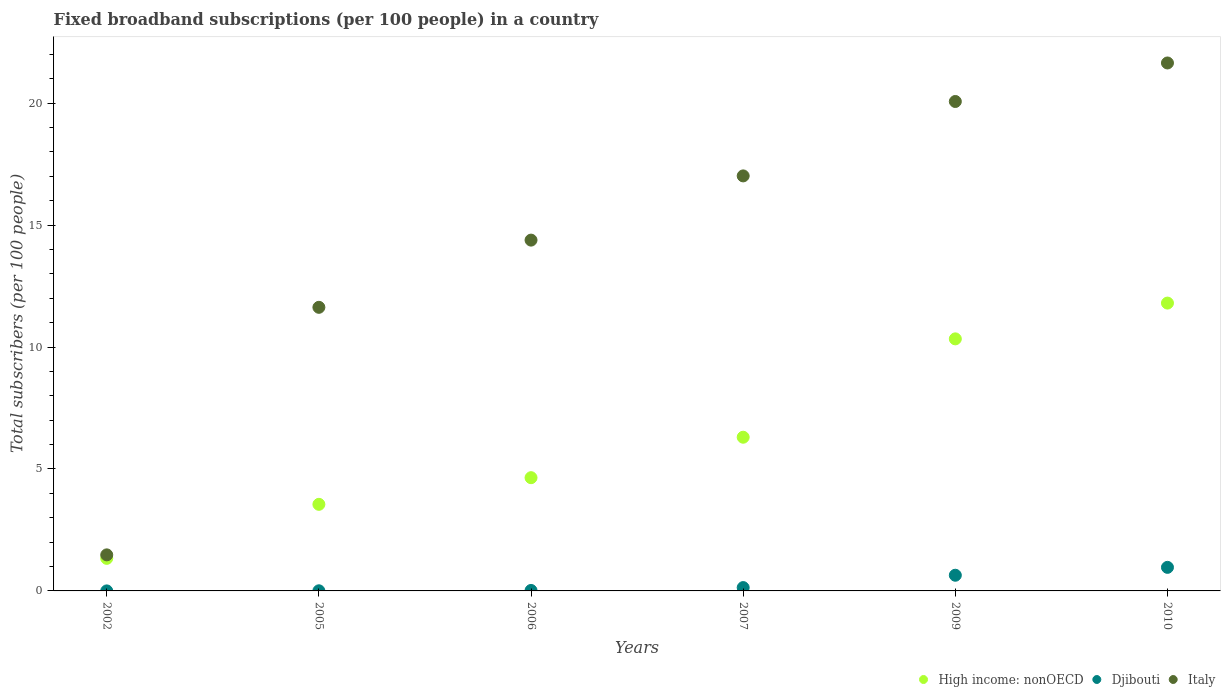What is the number of broadband subscriptions in Italy in 2009?
Provide a short and direct response. 20.07. Across all years, what is the maximum number of broadband subscriptions in Italy?
Provide a short and direct response. 21.65. Across all years, what is the minimum number of broadband subscriptions in Djibouti?
Make the answer very short. 0. In which year was the number of broadband subscriptions in Djibouti maximum?
Offer a terse response. 2010. What is the total number of broadband subscriptions in Djibouti in the graph?
Keep it short and to the point. 1.77. What is the difference between the number of broadband subscriptions in Italy in 2002 and that in 2005?
Keep it short and to the point. -10.15. What is the difference between the number of broadband subscriptions in Djibouti in 2002 and the number of broadband subscriptions in Italy in 2005?
Ensure brevity in your answer.  -11.63. What is the average number of broadband subscriptions in Djibouti per year?
Make the answer very short. 0.3. In the year 2006, what is the difference between the number of broadband subscriptions in High income: nonOECD and number of broadband subscriptions in Djibouti?
Your answer should be compact. 4.62. What is the ratio of the number of broadband subscriptions in High income: nonOECD in 2002 to that in 2009?
Your answer should be very brief. 0.13. Is the number of broadband subscriptions in High income: nonOECD in 2002 less than that in 2009?
Your answer should be very brief. Yes. Is the difference between the number of broadband subscriptions in High income: nonOECD in 2007 and 2009 greater than the difference between the number of broadband subscriptions in Djibouti in 2007 and 2009?
Make the answer very short. No. What is the difference between the highest and the second highest number of broadband subscriptions in Djibouti?
Offer a terse response. 0.32. What is the difference between the highest and the lowest number of broadband subscriptions in High income: nonOECD?
Your answer should be compact. 10.47. Is it the case that in every year, the sum of the number of broadband subscriptions in Italy and number of broadband subscriptions in High income: nonOECD  is greater than the number of broadband subscriptions in Djibouti?
Give a very brief answer. Yes. Does the number of broadband subscriptions in Italy monotonically increase over the years?
Keep it short and to the point. Yes. Is the number of broadband subscriptions in Italy strictly less than the number of broadband subscriptions in Djibouti over the years?
Make the answer very short. No. What is the difference between two consecutive major ticks on the Y-axis?
Keep it short and to the point. 5. Does the graph contain any zero values?
Make the answer very short. No. Where does the legend appear in the graph?
Ensure brevity in your answer.  Bottom right. How many legend labels are there?
Your answer should be compact. 3. What is the title of the graph?
Your answer should be compact. Fixed broadband subscriptions (per 100 people) in a country. Does "Switzerland" appear as one of the legend labels in the graph?
Your answer should be very brief. No. What is the label or title of the Y-axis?
Offer a very short reply. Total subscribers (per 100 people). What is the Total subscribers (per 100 people) of High income: nonOECD in 2002?
Offer a terse response. 1.34. What is the Total subscribers (per 100 people) in Djibouti in 2002?
Your answer should be compact. 0. What is the Total subscribers (per 100 people) in Italy in 2002?
Your answer should be very brief. 1.48. What is the Total subscribers (per 100 people) of High income: nonOECD in 2005?
Your response must be concise. 3.55. What is the Total subscribers (per 100 people) in Djibouti in 2005?
Your answer should be very brief. 0.01. What is the Total subscribers (per 100 people) of Italy in 2005?
Provide a short and direct response. 11.63. What is the Total subscribers (per 100 people) in High income: nonOECD in 2006?
Offer a terse response. 4.64. What is the Total subscribers (per 100 people) of Djibouti in 2006?
Provide a succinct answer. 0.02. What is the Total subscribers (per 100 people) in Italy in 2006?
Your answer should be very brief. 14.38. What is the Total subscribers (per 100 people) of High income: nonOECD in 2007?
Your answer should be very brief. 6.3. What is the Total subscribers (per 100 people) of Djibouti in 2007?
Keep it short and to the point. 0.14. What is the Total subscribers (per 100 people) in Italy in 2007?
Give a very brief answer. 17.02. What is the Total subscribers (per 100 people) in High income: nonOECD in 2009?
Your answer should be very brief. 10.33. What is the Total subscribers (per 100 people) of Djibouti in 2009?
Provide a succinct answer. 0.64. What is the Total subscribers (per 100 people) of Italy in 2009?
Your answer should be very brief. 20.07. What is the Total subscribers (per 100 people) in High income: nonOECD in 2010?
Your answer should be compact. 11.8. What is the Total subscribers (per 100 people) in Djibouti in 2010?
Keep it short and to the point. 0.97. What is the Total subscribers (per 100 people) of Italy in 2010?
Provide a succinct answer. 21.65. Across all years, what is the maximum Total subscribers (per 100 people) of High income: nonOECD?
Give a very brief answer. 11.8. Across all years, what is the maximum Total subscribers (per 100 people) in Djibouti?
Offer a very short reply. 0.97. Across all years, what is the maximum Total subscribers (per 100 people) of Italy?
Offer a very short reply. 21.65. Across all years, what is the minimum Total subscribers (per 100 people) in High income: nonOECD?
Make the answer very short. 1.34. Across all years, what is the minimum Total subscribers (per 100 people) in Djibouti?
Give a very brief answer. 0. Across all years, what is the minimum Total subscribers (per 100 people) of Italy?
Ensure brevity in your answer.  1.48. What is the total Total subscribers (per 100 people) of High income: nonOECD in the graph?
Provide a succinct answer. 37.97. What is the total Total subscribers (per 100 people) of Djibouti in the graph?
Your answer should be compact. 1.77. What is the total Total subscribers (per 100 people) of Italy in the graph?
Offer a terse response. 86.22. What is the difference between the Total subscribers (per 100 people) of High income: nonOECD in 2002 and that in 2005?
Give a very brief answer. -2.21. What is the difference between the Total subscribers (per 100 people) of Djibouti in 2002 and that in 2005?
Your response must be concise. -0. What is the difference between the Total subscribers (per 100 people) of Italy in 2002 and that in 2005?
Your answer should be very brief. -10.15. What is the difference between the Total subscribers (per 100 people) in High income: nonOECD in 2002 and that in 2006?
Provide a succinct answer. -3.31. What is the difference between the Total subscribers (per 100 people) in Djibouti in 2002 and that in 2006?
Provide a short and direct response. -0.02. What is the difference between the Total subscribers (per 100 people) of Italy in 2002 and that in 2006?
Your answer should be very brief. -12.91. What is the difference between the Total subscribers (per 100 people) of High income: nonOECD in 2002 and that in 2007?
Give a very brief answer. -4.97. What is the difference between the Total subscribers (per 100 people) in Djibouti in 2002 and that in 2007?
Your answer should be compact. -0.14. What is the difference between the Total subscribers (per 100 people) of Italy in 2002 and that in 2007?
Your response must be concise. -15.54. What is the difference between the Total subscribers (per 100 people) in High income: nonOECD in 2002 and that in 2009?
Your answer should be compact. -9. What is the difference between the Total subscribers (per 100 people) of Djibouti in 2002 and that in 2009?
Your answer should be very brief. -0.64. What is the difference between the Total subscribers (per 100 people) in Italy in 2002 and that in 2009?
Provide a succinct answer. -18.59. What is the difference between the Total subscribers (per 100 people) in High income: nonOECD in 2002 and that in 2010?
Provide a succinct answer. -10.47. What is the difference between the Total subscribers (per 100 people) of Djibouti in 2002 and that in 2010?
Provide a succinct answer. -0.97. What is the difference between the Total subscribers (per 100 people) in Italy in 2002 and that in 2010?
Offer a very short reply. -20.17. What is the difference between the Total subscribers (per 100 people) of High income: nonOECD in 2005 and that in 2006?
Offer a terse response. -1.09. What is the difference between the Total subscribers (per 100 people) in Djibouti in 2005 and that in 2006?
Your answer should be very brief. -0.01. What is the difference between the Total subscribers (per 100 people) in Italy in 2005 and that in 2006?
Ensure brevity in your answer.  -2.76. What is the difference between the Total subscribers (per 100 people) of High income: nonOECD in 2005 and that in 2007?
Ensure brevity in your answer.  -2.75. What is the difference between the Total subscribers (per 100 people) in Djibouti in 2005 and that in 2007?
Give a very brief answer. -0.13. What is the difference between the Total subscribers (per 100 people) in Italy in 2005 and that in 2007?
Give a very brief answer. -5.39. What is the difference between the Total subscribers (per 100 people) in High income: nonOECD in 2005 and that in 2009?
Make the answer very short. -6.78. What is the difference between the Total subscribers (per 100 people) in Djibouti in 2005 and that in 2009?
Provide a succinct answer. -0.64. What is the difference between the Total subscribers (per 100 people) of Italy in 2005 and that in 2009?
Your response must be concise. -8.44. What is the difference between the Total subscribers (per 100 people) of High income: nonOECD in 2005 and that in 2010?
Offer a very short reply. -8.25. What is the difference between the Total subscribers (per 100 people) in Djibouti in 2005 and that in 2010?
Provide a short and direct response. -0.96. What is the difference between the Total subscribers (per 100 people) of Italy in 2005 and that in 2010?
Ensure brevity in your answer.  -10.02. What is the difference between the Total subscribers (per 100 people) of High income: nonOECD in 2006 and that in 2007?
Offer a very short reply. -1.66. What is the difference between the Total subscribers (per 100 people) in Djibouti in 2006 and that in 2007?
Offer a very short reply. -0.12. What is the difference between the Total subscribers (per 100 people) of Italy in 2006 and that in 2007?
Your response must be concise. -2.63. What is the difference between the Total subscribers (per 100 people) of High income: nonOECD in 2006 and that in 2009?
Ensure brevity in your answer.  -5.69. What is the difference between the Total subscribers (per 100 people) of Djibouti in 2006 and that in 2009?
Make the answer very short. -0.62. What is the difference between the Total subscribers (per 100 people) in Italy in 2006 and that in 2009?
Offer a terse response. -5.68. What is the difference between the Total subscribers (per 100 people) in High income: nonOECD in 2006 and that in 2010?
Offer a terse response. -7.16. What is the difference between the Total subscribers (per 100 people) in Djibouti in 2006 and that in 2010?
Ensure brevity in your answer.  -0.95. What is the difference between the Total subscribers (per 100 people) of Italy in 2006 and that in 2010?
Your response must be concise. -7.26. What is the difference between the Total subscribers (per 100 people) of High income: nonOECD in 2007 and that in 2009?
Provide a short and direct response. -4.03. What is the difference between the Total subscribers (per 100 people) of Djibouti in 2007 and that in 2009?
Provide a short and direct response. -0.51. What is the difference between the Total subscribers (per 100 people) in Italy in 2007 and that in 2009?
Offer a very short reply. -3.05. What is the difference between the Total subscribers (per 100 people) of High income: nonOECD in 2007 and that in 2010?
Offer a terse response. -5.5. What is the difference between the Total subscribers (per 100 people) of Djibouti in 2007 and that in 2010?
Your answer should be compact. -0.83. What is the difference between the Total subscribers (per 100 people) in Italy in 2007 and that in 2010?
Keep it short and to the point. -4.63. What is the difference between the Total subscribers (per 100 people) of High income: nonOECD in 2009 and that in 2010?
Make the answer very short. -1.47. What is the difference between the Total subscribers (per 100 people) in Djibouti in 2009 and that in 2010?
Your answer should be compact. -0.32. What is the difference between the Total subscribers (per 100 people) in Italy in 2009 and that in 2010?
Offer a very short reply. -1.58. What is the difference between the Total subscribers (per 100 people) of High income: nonOECD in 2002 and the Total subscribers (per 100 people) of Djibouti in 2005?
Give a very brief answer. 1.33. What is the difference between the Total subscribers (per 100 people) in High income: nonOECD in 2002 and the Total subscribers (per 100 people) in Italy in 2005?
Your answer should be compact. -10.29. What is the difference between the Total subscribers (per 100 people) in Djibouti in 2002 and the Total subscribers (per 100 people) in Italy in 2005?
Your response must be concise. -11.63. What is the difference between the Total subscribers (per 100 people) in High income: nonOECD in 2002 and the Total subscribers (per 100 people) in Djibouti in 2006?
Give a very brief answer. 1.32. What is the difference between the Total subscribers (per 100 people) of High income: nonOECD in 2002 and the Total subscribers (per 100 people) of Italy in 2006?
Offer a terse response. -13.05. What is the difference between the Total subscribers (per 100 people) of Djibouti in 2002 and the Total subscribers (per 100 people) of Italy in 2006?
Provide a succinct answer. -14.38. What is the difference between the Total subscribers (per 100 people) in High income: nonOECD in 2002 and the Total subscribers (per 100 people) in Djibouti in 2007?
Provide a succinct answer. 1.2. What is the difference between the Total subscribers (per 100 people) of High income: nonOECD in 2002 and the Total subscribers (per 100 people) of Italy in 2007?
Provide a succinct answer. -15.68. What is the difference between the Total subscribers (per 100 people) of Djibouti in 2002 and the Total subscribers (per 100 people) of Italy in 2007?
Your answer should be compact. -17.02. What is the difference between the Total subscribers (per 100 people) in High income: nonOECD in 2002 and the Total subscribers (per 100 people) in Djibouti in 2009?
Give a very brief answer. 0.69. What is the difference between the Total subscribers (per 100 people) in High income: nonOECD in 2002 and the Total subscribers (per 100 people) in Italy in 2009?
Keep it short and to the point. -18.73. What is the difference between the Total subscribers (per 100 people) of Djibouti in 2002 and the Total subscribers (per 100 people) of Italy in 2009?
Your response must be concise. -20.07. What is the difference between the Total subscribers (per 100 people) in High income: nonOECD in 2002 and the Total subscribers (per 100 people) in Djibouti in 2010?
Offer a very short reply. 0.37. What is the difference between the Total subscribers (per 100 people) in High income: nonOECD in 2002 and the Total subscribers (per 100 people) in Italy in 2010?
Provide a short and direct response. -20.31. What is the difference between the Total subscribers (per 100 people) in Djibouti in 2002 and the Total subscribers (per 100 people) in Italy in 2010?
Your response must be concise. -21.65. What is the difference between the Total subscribers (per 100 people) in High income: nonOECD in 2005 and the Total subscribers (per 100 people) in Djibouti in 2006?
Provide a succinct answer. 3.53. What is the difference between the Total subscribers (per 100 people) of High income: nonOECD in 2005 and the Total subscribers (per 100 people) of Italy in 2006?
Offer a terse response. -10.83. What is the difference between the Total subscribers (per 100 people) of Djibouti in 2005 and the Total subscribers (per 100 people) of Italy in 2006?
Make the answer very short. -14.38. What is the difference between the Total subscribers (per 100 people) in High income: nonOECD in 2005 and the Total subscribers (per 100 people) in Djibouti in 2007?
Make the answer very short. 3.41. What is the difference between the Total subscribers (per 100 people) in High income: nonOECD in 2005 and the Total subscribers (per 100 people) in Italy in 2007?
Provide a short and direct response. -13.47. What is the difference between the Total subscribers (per 100 people) in Djibouti in 2005 and the Total subscribers (per 100 people) in Italy in 2007?
Your answer should be compact. -17.01. What is the difference between the Total subscribers (per 100 people) in High income: nonOECD in 2005 and the Total subscribers (per 100 people) in Djibouti in 2009?
Give a very brief answer. 2.91. What is the difference between the Total subscribers (per 100 people) of High income: nonOECD in 2005 and the Total subscribers (per 100 people) of Italy in 2009?
Provide a succinct answer. -16.52. What is the difference between the Total subscribers (per 100 people) of Djibouti in 2005 and the Total subscribers (per 100 people) of Italy in 2009?
Your answer should be compact. -20.06. What is the difference between the Total subscribers (per 100 people) in High income: nonOECD in 2005 and the Total subscribers (per 100 people) in Djibouti in 2010?
Ensure brevity in your answer.  2.58. What is the difference between the Total subscribers (per 100 people) of High income: nonOECD in 2005 and the Total subscribers (per 100 people) of Italy in 2010?
Offer a terse response. -18.1. What is the difference between the Total subscribers (per 100 people) of Djibouti in 2005 and the Total subscribers (per 100 people) of Italy in 2010?
Keep it short and to the point. -21.64. What is the difference between the Total subscribers (per 100 people) in High income: nonOECD in 2006 and the Total subscribers (per 100 people) in Djibouti in 2007?
Ensure brevity in your answer.  4.51. What is the difference between the Total subscribers (per 100 people) of High income: nonOECD in 2006 and the Total subscribers (per 100 people) of Italy in 2007?
Keep it short and to the point. -12.37. What is the difference between the Total subscribers (per 100 people) of Djibouti in 2006 and the Total subscribers (per 100 people) of Italy in 2007?
Your answer should be compact. -17. What is the difference between the Total subscribers (per 100 people) of High income: nonOECD in 2006 and the Total subscribers (per 100 people) of Djibouti in 2009?
Make the answer very short. 4. What is the difference between the Total subscribers (per 100 people) in High income: nonOECD in 2006 and the Total subscribers (per 100 people) in Italy in 2009?
Your answer should be very brief. -15.42. What is the difference between the Total subscribers (per 100 people) in Djibouti in 2006 and the Total subscribers (per 100 people) in Italy in 2009?
Provide a short and direct response. -20.05. What is the difference between the Total subscribers (per 100 people) of High income: nonOECD in 2006 and the Total subscribers (per 100 people) of Djibouti in 2010?
Make the answer very short. 3.68. What is the difference between the Total subscribers (per 100 people) in High income: nonOECD in 2006 and the Total subscribers (per 100 people) in Italy in 2010?
Give a very brief answer. -17. What is the difference between the Total subscribers (per 100 people) of Djibouti in 2006 and the Total subscribers (per 100 people) of Italy in 2010?
Offer a very short reply. -21.63. What is the difference between the Total subscribers (per 100 people) in High income: nonOECD in 2007 and the Total subscribers (per 100 people) in Djibouti in 2009?
Provide a succinct answer. 5.66. What is the difference between the Total subscribers (per 100 people) of High income: nonOECD in 2007 and the Total subscribers (per 100 people) of Italy in 2009?
Give a very brief answer. -13.77. What is the difference between the Total subscribers (per 100 people) of Djibouti in 2007 and the Total subscribers (per 100 people) of Italy in 2009?
Your response must be concise. -19.93. What is the difference between the Total subscribers (per 100 people) in High income: nonOECD in 2007 and the Total subscribers (per 100 people) in Djibouti in 2010?
Your answer should be very brief. 5.34. What is the difference between the Total subscribers (per 100 people) of High income: nonOECD in 2007 and the Total subscribers (per 100 people) of Italy in 2010?
Ensure brevity in your answer.  -15.34. What is the difference between the Total subscribers (per 100 people) in Djibouti in 2007 and the Total subscribers (per 100 people) in Italy in 2010?
Offer a very short reply. -21.51. What is the difference between the Total subscribers (per 100 people) of High income: nonOECD in 2009 and the Total subscribers (per 100 people) of Djibouti in 2010?
Provide a short and direct response. 9.37. What is the difference between the Total subscribers (per 100 people) in High income: nonOECD in 2009 and the Total subscribers (per 100 people) in Italy in 2010?
Keep it short and to the point. -11.31. What is the difference between the Total subscribers (per 100 people) of Djibouti in 2009 and the Total subscribers (per 100 people) of Italy in 2010?
Your response must be concise. -21. What is the average Total subscribers (per 100 people) of High income: nonOECD per year?
Your answer should be very brief. 6.33. What is the average Total subscribers (per 100 people) of Djibouti per year?
Provide a short and direct response. 0.3. What is the average Total subscribers (per 100 people) of Italy per year?
Make the answer very short. 14.37. In the year 2002, what is the difference between the Total subscribers (per 100 people) of High income: nonOECD and Total subscribers (per 100 people) of Djibouti?
Make the answer very short. 1.33. In the year 2002, what is the difference between the Total subscribers (per 100 people) of High income: nonOECD and Total subscribers (per 100 people) of Italy?
Give a very brief answer. -0.14. In the year 2002, what is the difference between the Total subscribers (per 100 people) in Djibouti and Total subscribers (per 100 people) in Italy?
Your answer should be very brief. -1.48. In the year 2005, what is the difference between the Total subscribers (per 100 people) in High income: nonOECD and Total subscribers (per 100 people) in Djibouti?
Your response must be concise. 3.54. In the year 2005, what is the difference between the Total subscribers (per 100 people) of High income: nonOECD and Total subscribers (per 100 people) of Italy?
Offer a very short reply. -8.08. In the year 2005, what is the difference between the Total subscribers (per 100 people) of Djibouti and Total subscribers (per 100 people) of Italy?
Provide a succinct answer. -11.62. In the year 2006, what is the difference between the Total subscribers (per 100 people) of High income: nonOECD and Total subscribers (per 100 people) of Djibouti?
Keep it short and to the point. 4.62. In the year 2006, what is the difference between the Total subscribers (per 100 people) of High income: nonOECD and Total subscribers (per 100 people) of Italy?
Offer a terse response. -9.74. In the year 2006, what is the difference between the Total subscribers (per 100 people) of Djibouti and Total subscribers (per 100 people) of Italy?
Give a very brief answer. -14.36. In the year 2007, what is the difference between the Total subscribers (per 100 people) of High income: nonOECD and Total subscribers (per 100 people) of Djibouti?
Give a very brief answer. 6.16. In the year 2007, what is the difference between the Total subscribers (per 100 people) of High income: nonOECD and Total subscribers (per 100 people) of Italy?
Ensure brevity in your answer.  -10.71. In the year 2007, what is the difference between the Total subscribers (per 100 people) in Djibouti and Total subscribers (per 100 people) in Italy?
Make the answer very short. -16.88. In the year 2009, what is the difference between the Total subscribers (per 100 people) in High income: nonOECD and Total subscribers (per 100 people) in Djibouti?
Provide a succinct answer. 9.69. In the year 2009, what is the difference between the Total subscribers (per 100 people) in High income: nonOECD and Total subscribers (per 100 people) in Italy?
Make the answer very short. -9.73. In the year 2009, what is the difference between the Total subscribers (per 100 people) of Djibouti and Total subscribers (per 100 people) of Italy?
Provide a short and direct response. -19.42. In the year 2010, what is the difference between the Total subscribers (per 100 people) of High income: nonOECD and Total subscribers (per 100 people) of Djibouti?
Ensure brevity in your answer.  10.84. In the year 2010, what is the difference between the Total subscribers (per 100 people) in High income: nonOECD and Total subscribers (per 100 people) in Italy?
Give a very brief answer. -9.84. In the year 2010, what is the difference between the Total subscribers (per 100 people) in Djibouti and Total subscribers (per 100 people) in Italy?
Offer a very short reply. -20.68. What is the ratio of the Total subscribers (per 100 people) of High income: nonOECD in 2002 to that in 2005?
Provide a succinct answer. 0.38. What is the ratio of the Total subscribers (per 100 people) of Djibouti in 2002 to that in 2005?
Your answer should be compact. 0.15. What is the ratio of the Total subscribers (per 100 people) of Italy in 2002 to that in 2005?
Your answer should be very brief. 0.13. What is the ratio of the Total subscribers (per 100 people) in High income: nonOECD in 2002 to that in 2006?
Keep it short and to the point. 0.29. What is the ratio of the Total subscribers (per 100 people) of Djibouti in 2002 to that in 2006?
Keep it short and to the point. 0.04. What is the ratio of the Total subscribers (per 100 people) of Italy in 2002 to that in 2006?
Offer a terse response. 0.1. What is the ratio of the Total subscribers (per 100 people) of High income: nonOECD in 2002 to that in 2007?
Your answer should be very brief. 0.21. What is the ratio of the Total subscribers (per 100 people) of Djibouti in 2002 to that in 2007?
Your response must be concise. 0.01. What is the ratio of the Total subscribers (per 100 people) of Italy in 2002 to that in 2007?
Make the answer very short. 0.09. What is the ratio of the Total subscribers (per 100 people) in High income: nonOECD in 2002 to that in 2009?
Offer a very short reply. 0.13. What is the ratio of the Total subscribers (per 100 people) in Djibouti in 2002 to that in 2009?
Provide a short and direct response. 0. What is the ratio of the Total subscribers (per 100 people) in Italy in 2002 to that in 2009?
Offer a very short reply. 0.07. What is the ratio of the Total subscribers (per 100 people) in High income: nonOECD in 2002 to that in 2010?
Ensure brevity in your answer.  0.11. What is the ratio of the Total subscribers (per 100 people) of Djibouti in 2002 to that in 2010?
Provide a short and direct response. 0. What is the ratio of the Total subscribers (per 100 people) of Italy in 2002 to that in 2010?
Offer a terse response. 0.07. What is the ratio of the Total subscribers (per 100 people) of High income: nonOECD in 2005 to that in 2006?
Ensure brevity in your answer.  0.76. What is the ratio of the Total subscribers (per 100 people) of Djibouti in 2005 to that in 2006?
Your response must be concise. 0.28. What is the ratio of the Total subscribers (per 100 people) in Italy in 2005 to that in 2006?
Your answer should be very brief. 0.81. What is the ratio of the Total subscribers (per 100 people) of High income: nonOECD in 2005 to that in 2007?
Your answer should be compact. 0.56. What is the ratio of the Total subscribers (per 100 people) in Djibouti in 2005 to that in 2007?
Ensure brevity in your answer.  0.04. What is the ratio of the Total subscribers (per 100 people) of Italy in 2005 to that in 2007?
Your answer should be very brief. 0.68. What is the ratio of the Total subscribers (per 100 people) in High income: nonOECD in 2005 to that in 2009?
Ensure brevity in your answer.  0.34. What is the ratio of the Total subscribers (per 100 people) of Djibouti in 2005 to that in 2009?
Your answer should be compact. 0.01. What is the ratio of the Total subscribers (per 100 people) of Italy in 2005 to that in 2009?
Ensure brevity in your answer.  0.58. What is the ratio of the Total subscribers (per 100 people) in High income: nonOECD in 2005 to that in 2010?
Make the answer very short. 0.3. What is the ratio of the Total subscribers (per 100 people) of Djibouti in 2005 to that in 2010?
Your answer should be very brief. 0.01. What is the ratio of the Total subscribers (per 100 people) of Italy in 2005 to that in 2010?
Your answer should be very brief. 0.54. What is the ratio of the Total subscribers (per 100 people) of High income: nonOECD in 2006 to that in 2007?
Provide a short and direct response. 0.74. What is the ratio of the Total subscribers (per 100 people) in Djibouti in 2006 to that in 2007?
Your answer should be very brief. 0.14. What is the ratio of the Total subscribers (per 100 people) in Italy in 2006 to that in 2007?
Offer a very short reply. 0.85. What is the ratio of the Total subscribers (per 100 people) of High income: nonOECD in 2006 to that in 2009?
Provide a succinct answer. 0.45. What is the ratio of the Total subscribers (per 100 people) of Italy in 2006 to that in 2009?
Your answer should be very brief. 0.72. What is the ratio of the Total subscribers (per 100 people) in High income: nonOECD in 2006 to that in 2010?
Provide a succinct answer. 0.39. What is the ratio of the Total subscribers (per 100 people) in Italy in 2006 to that in 2010?
Your answer should be very brief. 0.66. What is the ratio of the Total subscribers (per 100 people) of High income: nonOECD in 2007 to that in 2009?
Your answer should be compact. 0.61. What is the ratio of the Total subscribers (per 100 people) of Djibouti in 2007 to that in 2009?
Ensure brevity in your answer.  0.21. What is the ratio of the Total subscribers (per 100 people) of Italy in 2007 to that in 2009?
Provide a succinct answer. 0.85. What is the ratio of the Total subscribers (per 100 people) in High income: nonOECD in 2007 to that in 2010?
Your answer should be compact. 0.53. What is the ratio of the Total subscribers (per 100 people) in Djibouti in 2007 to that in 2010?
Your answer should be compact. 0.14. What is the ratio of the Total subscribers (per 100 people) in Italy in 2007 to that in 2010?
Provide a short and direct response. 0.79. What is the ratio of the Total subscribers (per 100 people) in High income: nonOECD in 2009 to that in 2010?
Your response must be concise. 0.88. What is the ratio of the Total subscribers (per 100 people) of Djibouti in 2009 to that in 2010?
Ensure brevity in your answer.  0.67. What is the ratio of the Total subscribers (per 100 people) in Italy in 2009 to that in 2010?
Give a very brief answer. 0.93. What is the difference between the highest and the second highest Total subscribers (per 100 people) in High income: nonOECD?
Your response must be concise. 1.47. What is the difference between the highest and the second highest Total subscribers (per 100 people) of Djibouti?
Keep it short and to the point. 0.32. What is the difference between the highest and the second highest Total subscribers (per 100 people) of Italy?
Offer a terse response. 1.58. What is the difference between the highest and the lowest Total subscribers (per 100 people) in High income: nonOECD?
Your answer should be very brief. 10.47. What is the difference between the highest and the lowest Total subscribers (per 100 people) of Djibouti?
Give a very brief answer. 0.97. What is the difference between the highest and the lowest Total subscribers (per 100 people) in Italy?
Provide a short and direct response. 20.17. 